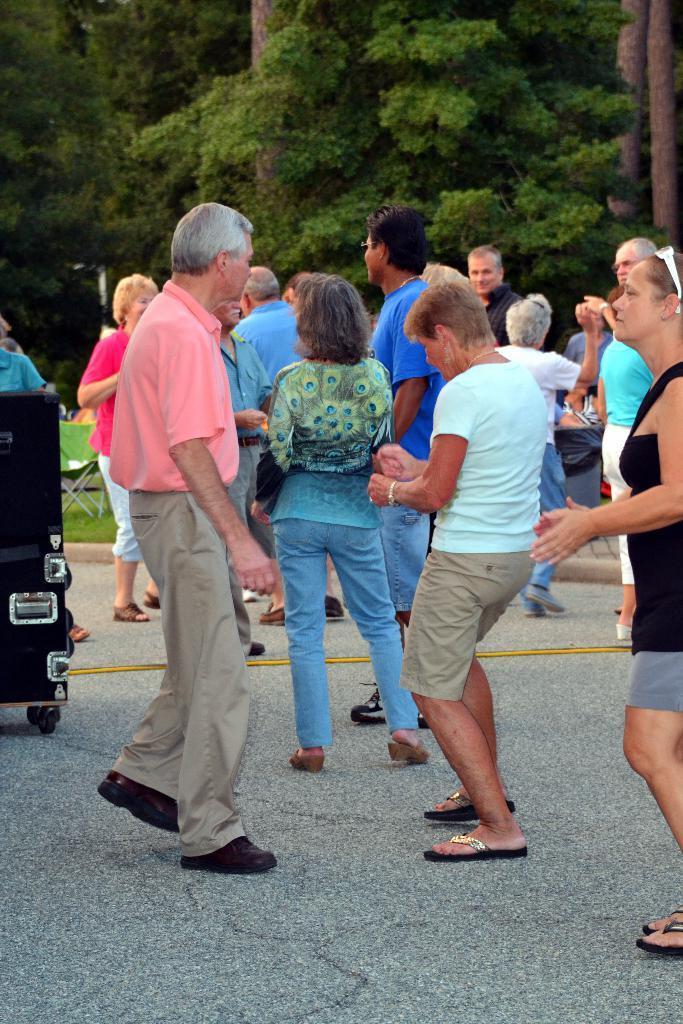In one or two sentences, can you explain what this image depicts? In this image we can see some people and other objects. In the background of the image there are trees, poles and the grass. At the bottom of the image there is the grass. 